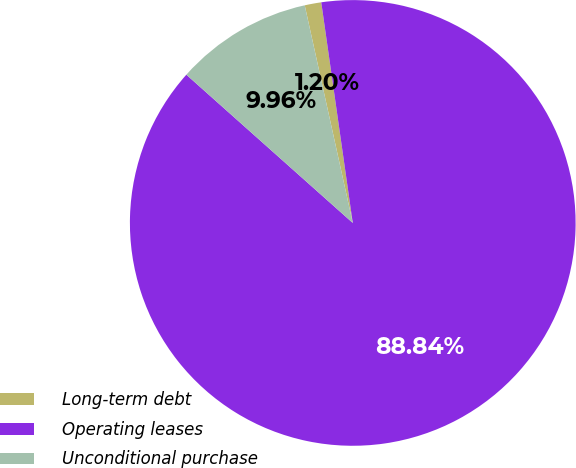Convert chart to OTSL. <chart><loc_0><loc_0><loc_500><loc_500><pie_chart><fcel>Long-term debt<fcel>Operating leases<fcel>Unconditional purchase<nl><fcel>1.2%<fcel>88.84%<fcel>9.96%<nl></chart> 